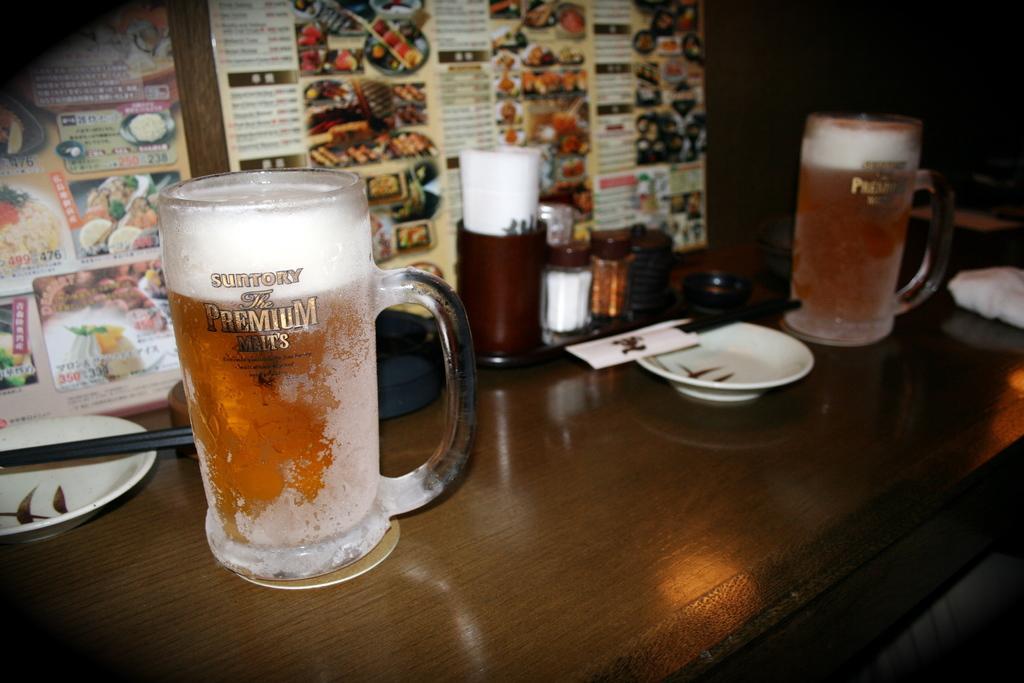How would you summarize this image in a sentence or two? In the image there is a table. To the right and left there are two mugs. To the left there is a plate with the chopsticks. In the center there are some jars, tissues and one plate. In the background there is a food menu. 